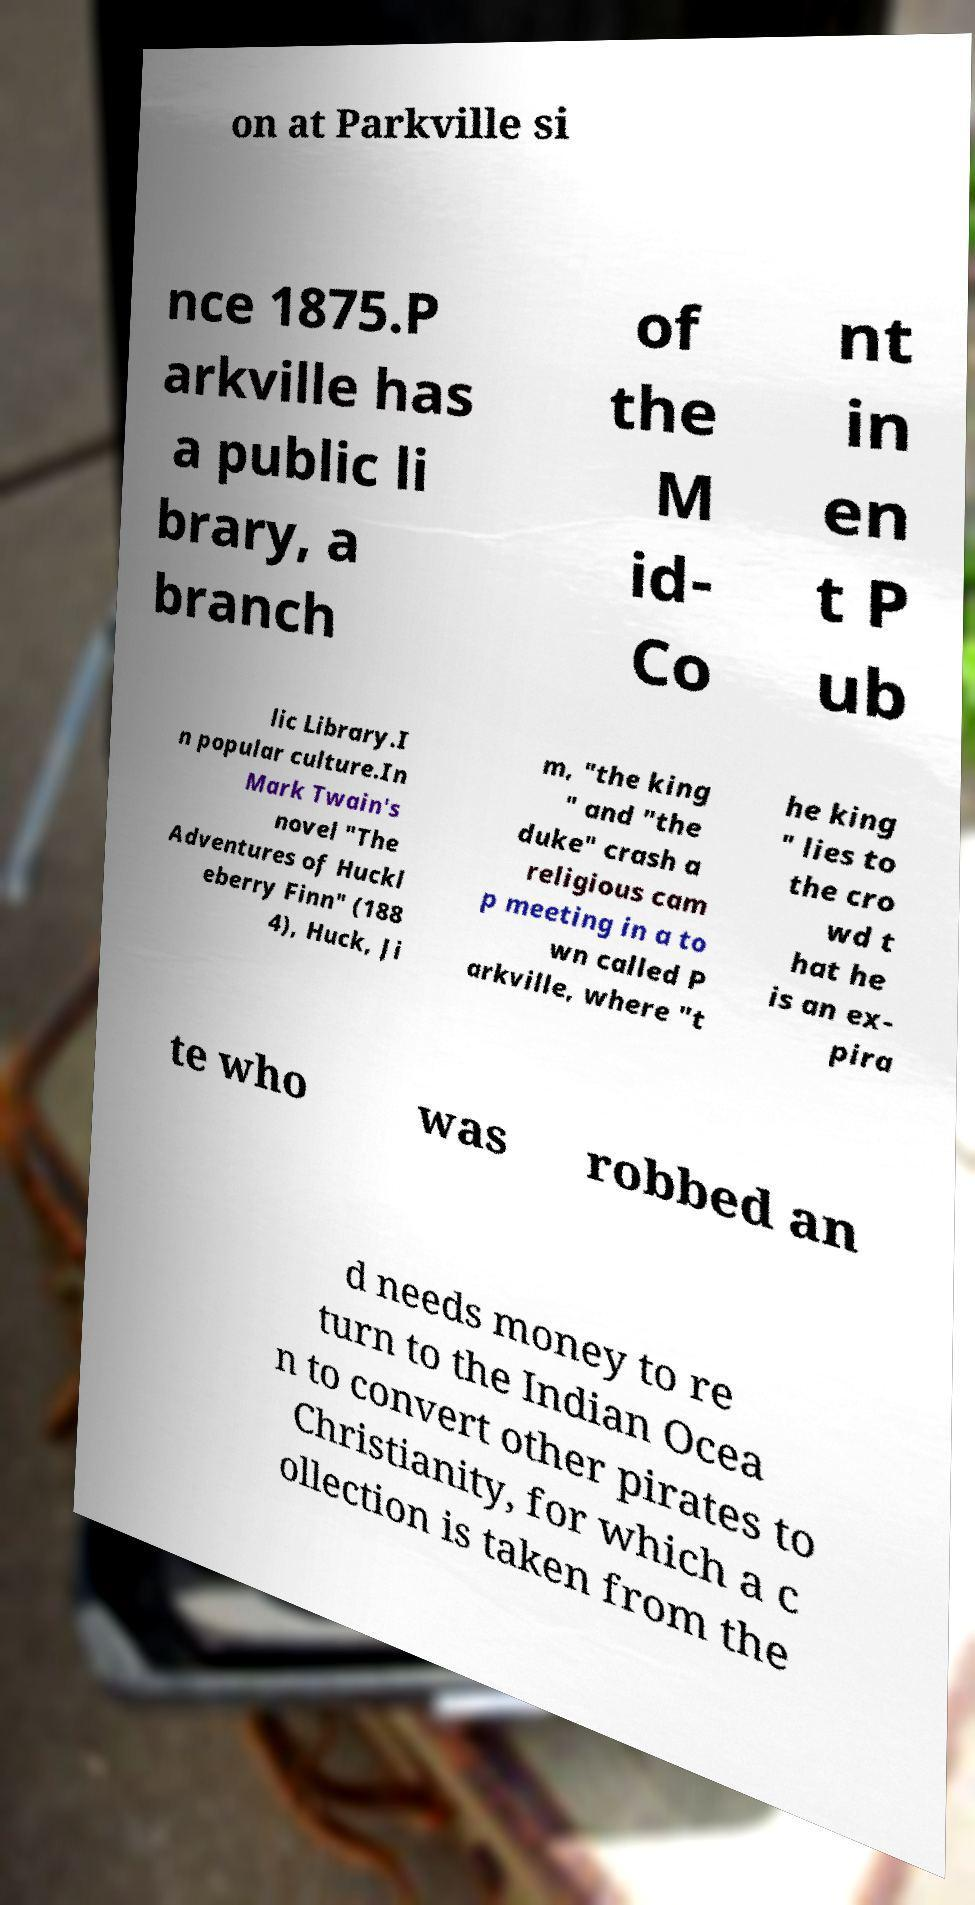There's text embedded in this image that I need extracted. Can you transcribe it verbatim? on at Parkville si nce 1875.P arkville has a public li brary, a branch of the M id- Co nt in en t P ub lic Library.I n popular culture.In Mark Twain's novel "The Adventures of Huckl eberry Finn" (188 4), Huck, Ji m, "the king " and "the duke" crash a religious cam p meeting in a to wn called P arkville, where "t he king " lies to the cro wd t hat he is an ex- pira te who was robbed an d needs money to re turn to the Indian Ocea n to convert other pirates to Christianity, for which a c ollection is taken from the 